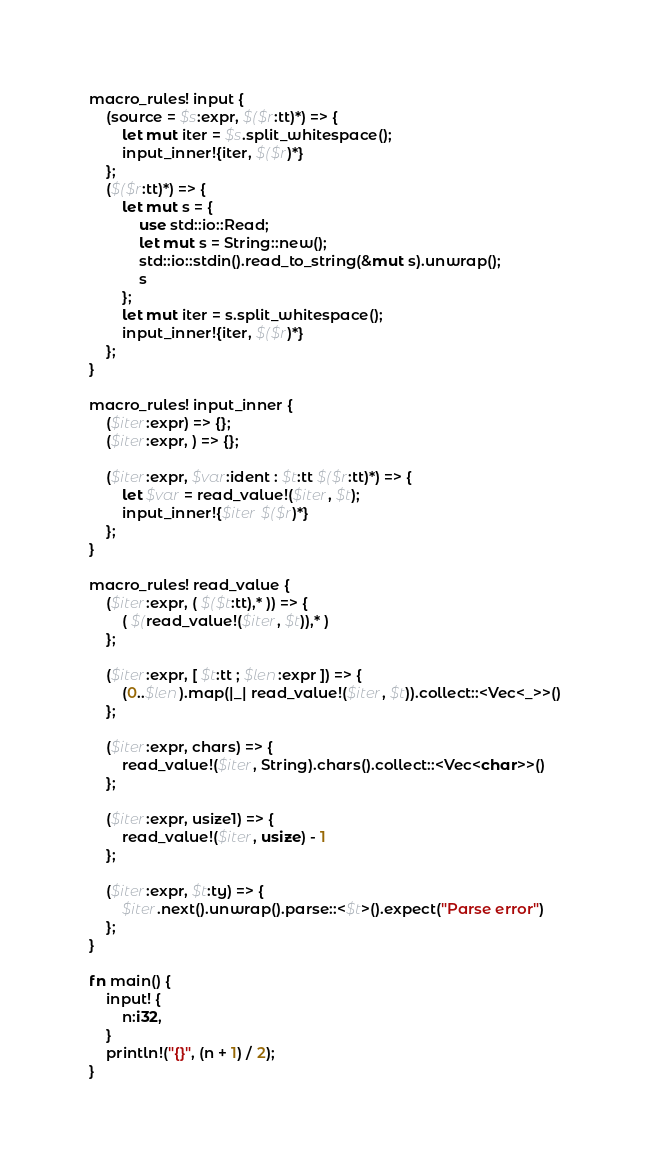<code> <loc_0><loc_0><loc_500><loc_500><_Rust_>macro_rules! input {
    (source = $s:expr, $($r:tt)*) => {
        let mut iter = $s.split_whitespace();
        input_inner!{iter, $($r)*}
    };
    ($($r:tt)*) => {
        let mut s = {
            use std::io::Read;
            let mut s = String::new();
            std::io::stdin().read_to_string(&mut s).unwrap();
            s
        };
        let mut iter = s.split_whitespace();
        input_inner!{iter, $($r)*}
    };
}

macro_rules! input_inner {
    ($iter:expr) => {};
    ($iter:expr, ) => {};

    ($iter:expr, $var:ident : $t:tt $($r:tt)*) => {
        let $var = read_value!($iter, $t);
        input_inner!{$iter $($r)*}
    };
}

macro_rules! read_value {
    ($iter:expr, ( $($t:tt),* )) => {
        ( $(read_value!($iter, $t)),* )
    };

    ($iter:expr, [ $t:tt ; $len:expr ]) => {
        (0..$len).map(|_| read_value!($iter, $t)).collect::<Vec<_>>()
    };

    ($iter:expr, chars) => {
        read_value!($iter, String).chars().collect::<Vec<char>>()
    };

    ($iter:expr, usize1) => {
        read_value!($iter, usize) - 1
    };

    ($iter:expr, $t:ty) => {
        $iter.next().unwrap().parse::<$t>().expect("Parse error")
    };
}

fn main() {
    input! {
        n:i32,
    }
    println!("{}", (n + 1) / 2);
}
</code> 